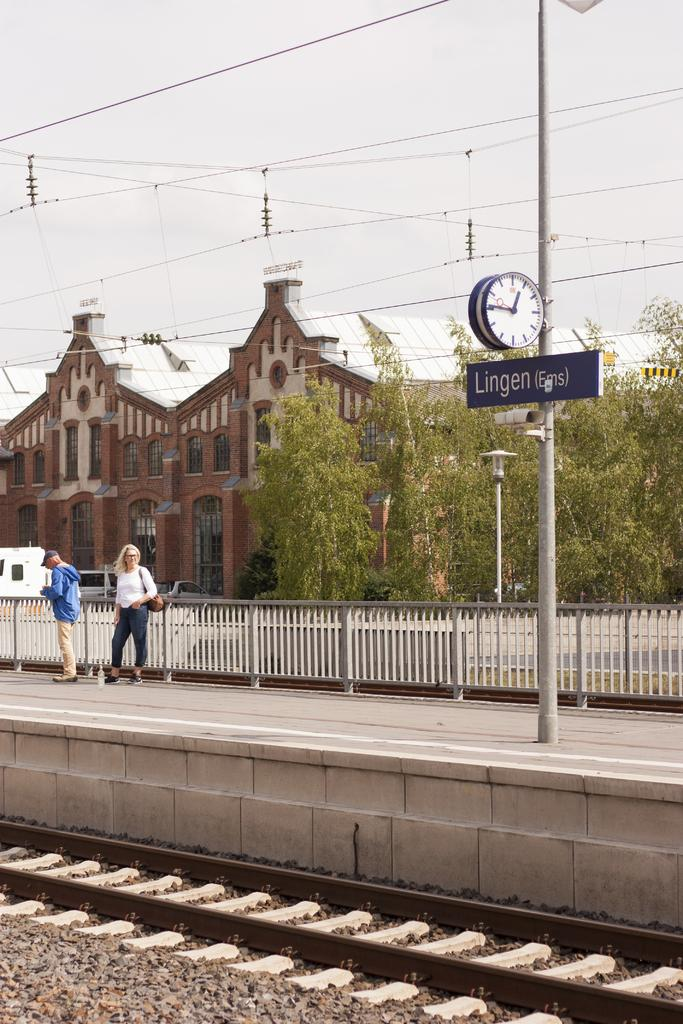<image>
Give a short and clear explanation of the subsequent image. Two women at the Lingen train station waiting for a train during the day 